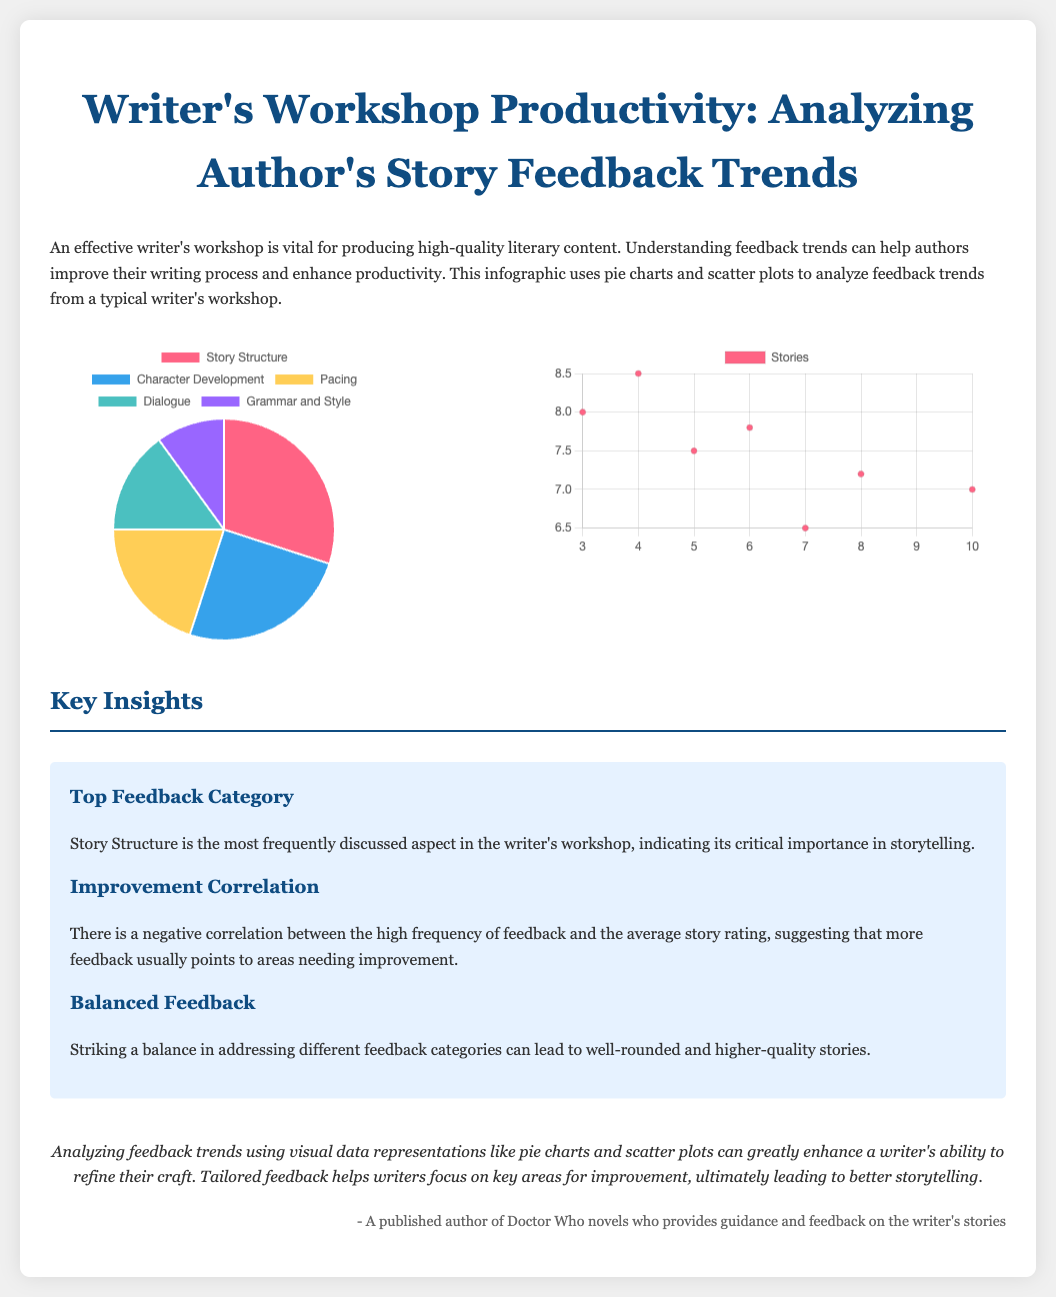What is the most frequently discussed feedback category? The most frequently discussed aspect in the writer's workshop is the one highlighted in the pie chart, which is critical for storytelling.
Answer: Story Structure What percentage of feedback is on Character Development? The percentage of feedback for Character Development can be found in the pie chart, showing its share in the total feedback categories.
Answer: 25 What does the scatter plot represent? The scatter plot illustrates the relationship between two specific aspects as evidenced by the x and y axes in the chart.
Answer: Feedback Frequency and Story Ratings What is the average story rating for a feedback frequency of 6? The average story rating corresponds to the data point indicated in the scatter plot for a feedback frequency of 6.
Answer: 7.8 What key correlation is identified in the document? The document discusses a specific type of relationship that impacts the quality of stories, highlighting important aspects of the feedback.
Answer: Negative correlation How many feedback categories are depicted in the pie chart? The number of different segments represented in the pie chart provides insight into the diversity of feedback discussed in workshops.
Answer: 5 What color represents Grammar and Style in the pie chart? The color for a specific feedback category can be identified by analyzing the legend associated with the pie chart.
Answer: Purple Which section of the infographic discusses balanced feedback? The mention of balanced feedback is highlighted in a specific section that addresses how it contributes to overall story quality.
Answer: Key Insights What is the unique feature of the document compared to regular reports? The document utilizes specific visual data representations that provide clarity and insight into author feedback.
Answer: Infographic with charts 